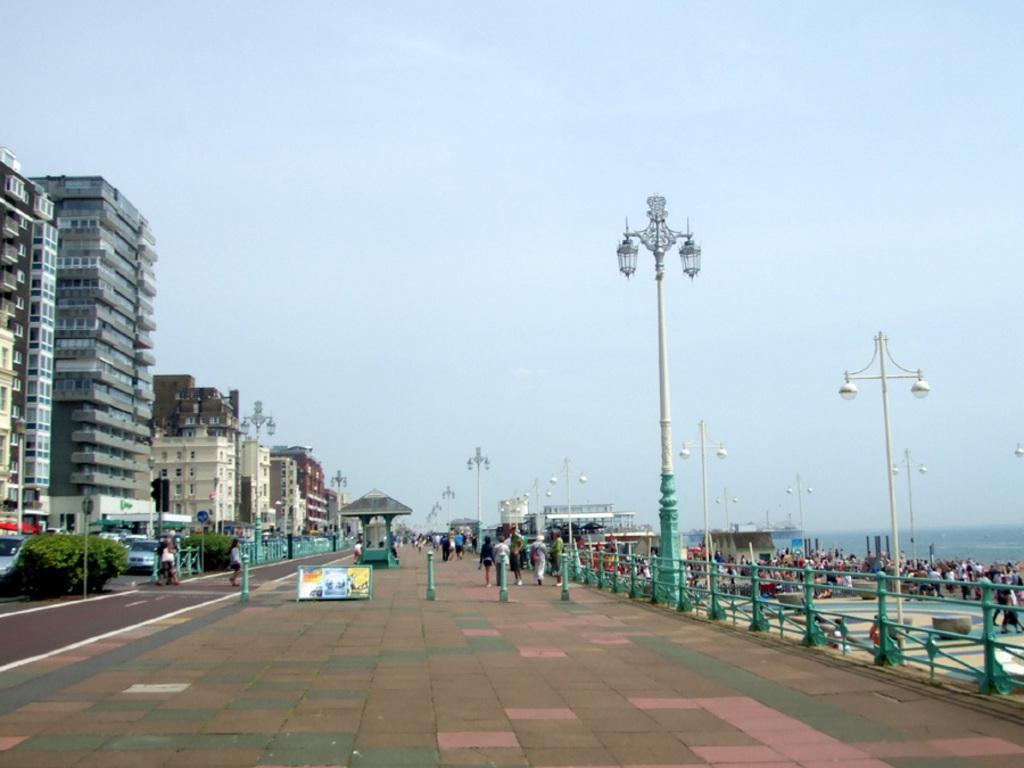Please provide a concise description of this image. In the image there is a footpath in the middle with many people walking on it, on the left side there are buildings with vehicles moving in front of it on the road, on the right side there is beach with many people in front of it and above its sky. 